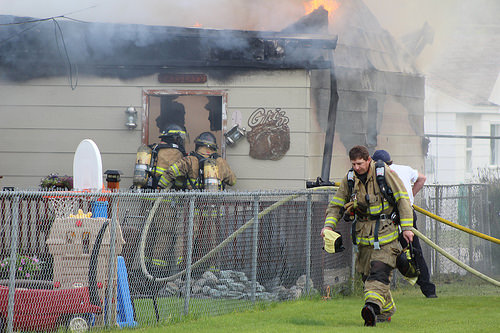<image>
Is there a fence behind the man? Yes. From this viewpoint, the fence is positioned behind the man, with the man partially or fully occluding the fence. 